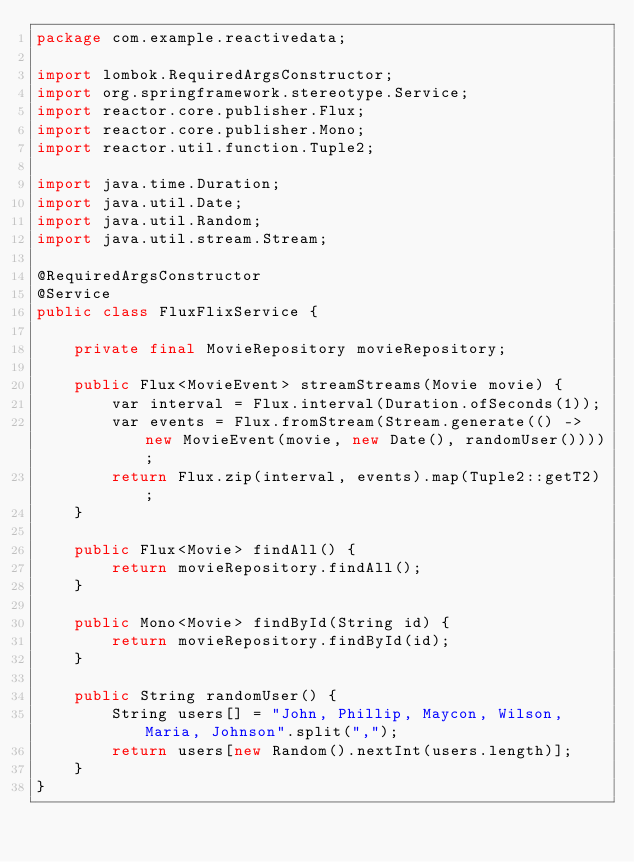Convert code to text. <code><loc_0><loc_0><loc_500><loc_500><_Java_>package com.example.reactivedata;

import lombok.RequiredArgsConstructor;
import org.springframework.stereotype.Service;
import reactor.core.publisher.Flux;
import reactor.core.publisher.Mono;
import reactor.util.function.Tuple2;

import java.time.Duration;
import java.util.Date;
import java.util.Random;
import java.util.stream.Stream;

@RequiredArgsConstructor
@Service
public class FluxFlixService {

    private final MovieRepository movieRepository;

    public Flux<MovieEvent> streamStreams(Movie movie) {
        var interval = Flux.interval(Duration.ofSeconds(1));
        var events = Flux.fromStream(Stream.generate(() -> new MovieEvent(movie, new Date(), randomUser())));
        return Flux.zip(interval, events).map(Tuple2::getT2);
    }

    public Flux<Movie> findAll() {
        return movieRepository.findAll();
    }

    public Mono<Movie> findById(String id) {
        return movieRepository.findById(id);
    }

    public String randomUser() {
        String users[] = "John, Phillip, Maycon, Wilson, Maria, Johnson".split(",");
        return users[new Random().nextInt(users.length)];
    }
}

</code> 